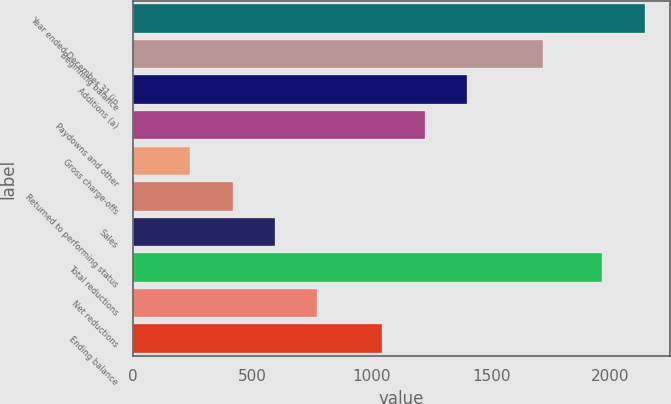Convert chart. <chart><loc_0><loc_0><loc_500><loc_500><bar_chart><fcel>Year ended December 31 (in<fcel>Beginning balance<fcel>Additions (a)<fcel>Paydowns and other<fcel>Gross charge-offs<fcel>Returned to performing status<fcel>Sales<fcel>Total reductions<fcel>Net reductions<fcel>Ending balance<nl><fcel>2143.2<fcel>1717<fcel>1398.4<fcel>1221.2<fcel>241<fcel>418.2<fcel>595.4<fcel>1966<fcel>772.6<fcel>1044<nl></chart> 